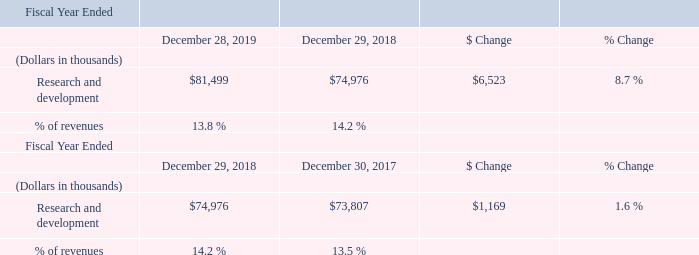Research and Development
The increase in research and development expenses in fiscal 2019 compared to fiscal 2018 was primarily driven by an increase in employee compensation costs caused by increases in headcount, annual compensation and benefit adjustments and employee performance-based compensation, partially offset by a decrease in project material costs.
What led to increase in research and development expenses in fiscal 2019 compared to fiscal 2018? The increase in research and development expenses in fiscal 2019 compared to fiscal 2018 was primarily driven by an increase in employee compensation costs. What is the average Research and development for the Fiscal Year Ended December 28, 2019 to December 29, 2018?  
Answer scale should be: thousand. (81,499+74,976) / 2
Answer: 78237.5. What is the average Research and development for the Fiscal Year Ended December 29, 2018 to December 30, 2017?
Answer scale should be: thousand. (74,976+73,807) / 2
Answer: 74391.5. In which year was Research and development less than 80,000 thousands? Locate and analyze research and development in row 4
answer: 2018. What was the % of revenues in 2019 and 2018? 13.8 %, 14.2 %. What was the change in Research and development from 2018 to 2019?
Answer scale should be: thousand. $6,523. 